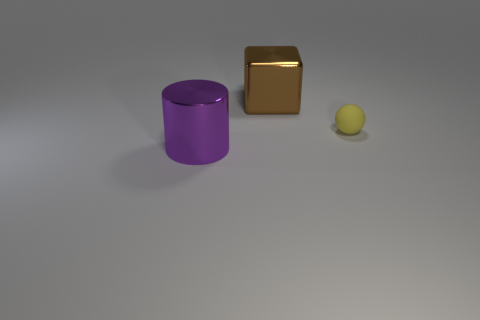Add 2 big blue matte things. How many objects exist? 5 Subtract all cylinders. How many objects are left? 2 Subtract all cubes. Subtract all purple shiny cylinders. How many objects are left? 1 Add 1 small yellow matte objects. How many small yellow matte objects are left? 2 Add 1 matte blocks. How many matte blocks exist? 1 Subtract 0 purple cubes. How many objects are left? 3 